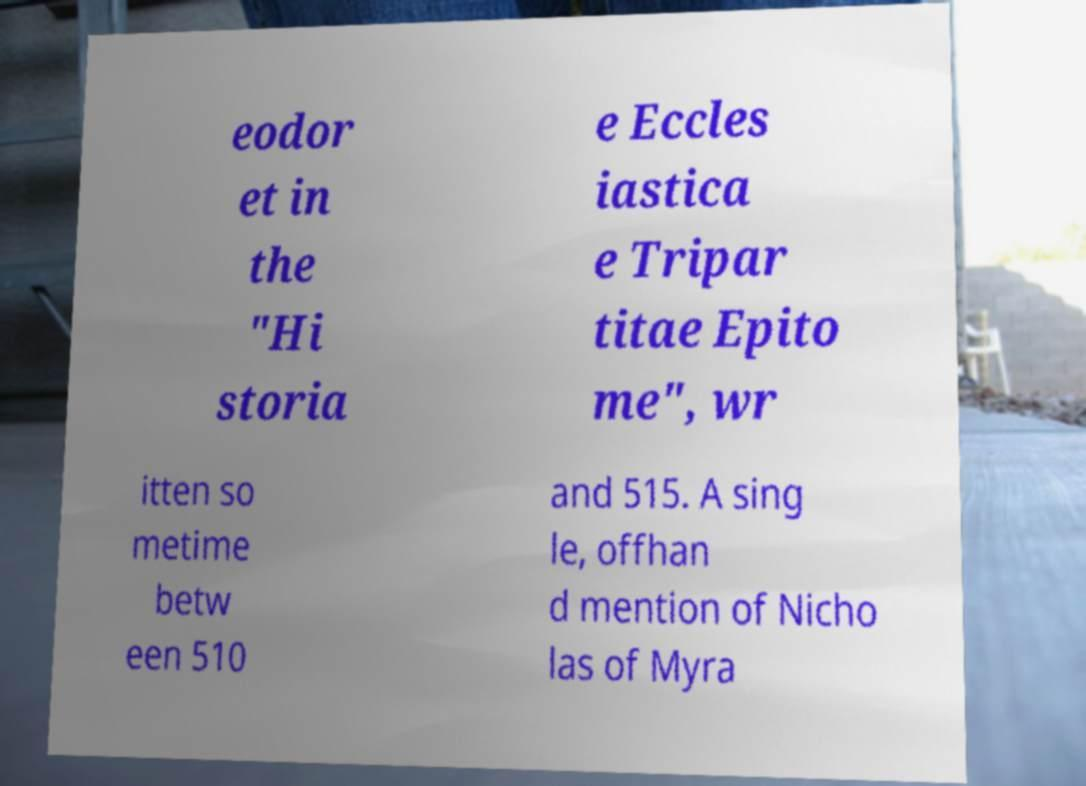There's text embedded in this image that I need extracted. Can you transcribe it verbatim? eodor et in the "Hi storia e Eccles iastica e Tripar titae Epito me", wr itten so metime betw een 510 and 515. A sing le, offhan d mention of Nicho las of Myra 